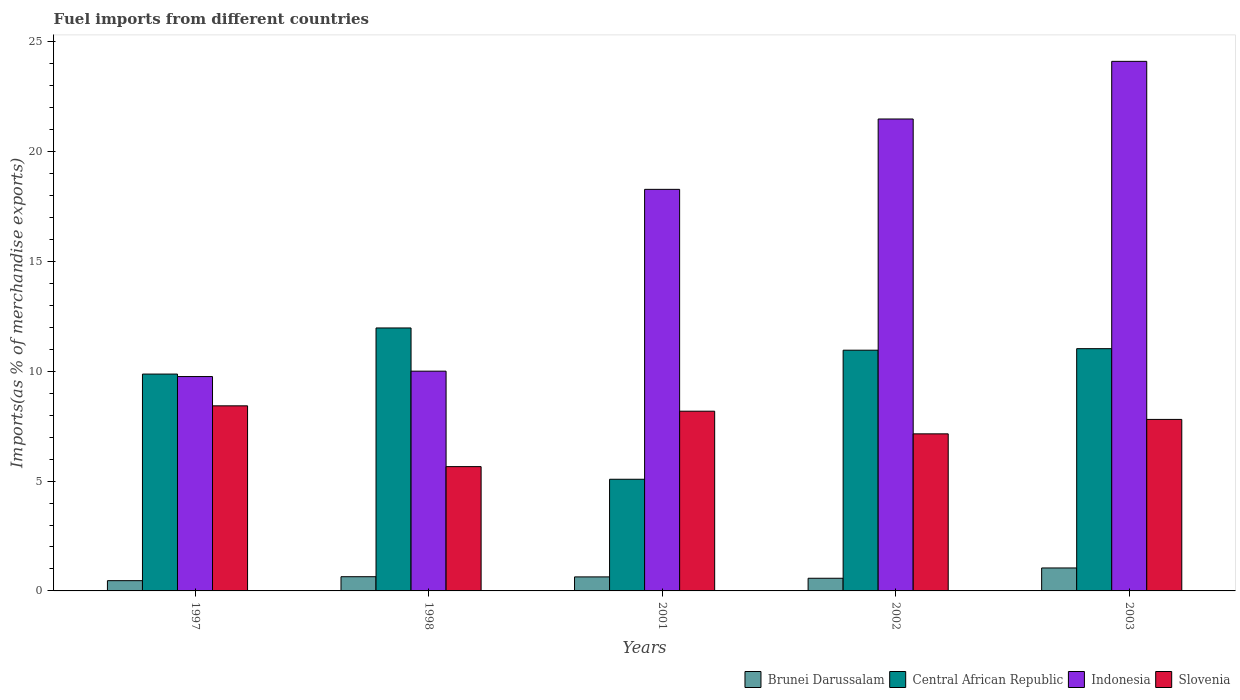How many groups of bars are there?
Give a very brief answer. 5. Are the number of bars per tick equal to the number of legend labels?
Offer a very short reply. Yes. Are the number of bars on each tick of the X-axis equal?
Ensure brevity in your answer.  Yes. How many bars are there on the 3rd tick from the left?
Provide a succinct answer. 4. How many bars are there on the 5th tick from the right?
Ensure brevity in your answer.  4. What is the label of the 2nd group of bars from the left?
Offer a very short reply. 1998. In how many cases, is the number of bars for a given year not equal to the number of legend labels?
Your response must be concise. 0. What is the percentage of imports to different countries in Slovenia in 1998?
Ensure brevity in your answer.  5.66. Across all years, what is the maximum percentage of imports to different countries in Brunei Darussalam?
Your answer should be compact. 1.05. Across all years, what is the minimum percentage of imports to different countries in Brunei Darussalam?
Offer a terse response. 0.47. In which year was the percentage of imports to different countries in Central African Republic maximum?
Your answer should be very brief. 1998. What is the total percentage of imports to different countries in Brunei Darussalam in the graph?
Make the answer very short. 3.37. What is the difference between the percentage of imports to different countries in Central African Republic in 1997 and that in 2002?
Provide a succinct answer. -1.09. What is the difference between the percentage of imports to different countries in Central African Republic in 2003 and the percentage of imports to different countries in Indonesia in 1998?
Ensure brevity in your answer.  1.02. What is the average percentage of imports to different countries in Indonesia per year?
Provide a succinct answer. 16.73. In the year 2001, what is the difference between the percentage of imports to different countries in Central African Republic and percentage of imports to different countries in Brunei Darussalam?
Ensure brevity in your answer.  4.45. What is the ratio of the percentage of imports to different countries in Indonesia in 1997 to that in 2002?
Provide a short and direct response. 0.45. Is the percentage of imports to different countries in Central African Republic in 2002 less than that in 2003?
Give a very brief answer. Yes. Is the difference between the percentage of imports to different countries in Central African Republic in 2002 and 2003 greater than the difference between the percentage of imports to different countries in Brunei Darussalam in 2002 and 2003?
Your answer should be compact. Yes. What is the difference between the highest and the second highest percentage of imports to different countries in Slovenia?
Make the answer very short. 0.24. What is the difference between the highest and the lowest percentage of imports to different countries in Central African Republic?
Provide a short and direct response. 6.89. In how many years, is the percentage of imports to different countries in Central African Republic greater than the average percentage of imports to different countries in Central African Republic taken over all years?
Your response must be concise. 4. Is the sum of the percentage of imports to different countries in Indonesia in 1998 and 2002 greater than the maximum percentage of imports to different countries in Central African Republic across all years?
Your answer should be compact. Yes. What does the 1st bar from the left in 2002 represents?
Your answer should be compact. Brunei Darussalam. What does the 4th bar from the right in 1997 represents?
Your response must be concise. Brunei Darussalam. How many bars are there?
Offer a terse response. 20. Are all the bars in the graph horizontal?
Offer a terse response. No. How many years are there in the graph?
Keep it short and to the point. 5. What is the difference between two consecutive major ticks on the Y-axis?
Give a very brief answer. 5. How many legend labels are there?
Give a very brief answer. 4. What is the title of the graph?
Ensure brevity in your answer.  Fuel imports from different countries. What is the label or title of the X-axis?
Your response must be concise. Years. What is the label or title of the Y-axis?
Keep it short and to the point. Imports(as % of merchandise exports). What is the Imports(as % of merchandise exports) in Brunei Darussalam in 1997?
Your answer should be very brief. 0.47. What is the Imports(as % of merchandise exports) in Central African Republic in 1997?
Ensure brevity in your answer.  9.87. What is the Imports(as % of merchandise exports) in Indonesia in 1997?
Your response must be concise. 9.76. What is the Imports(as % of merchandise exports) in Slovenia in 1997?
Keep it short and to the point. 8.43. What is the Imports(as % of merchandise exports) in Brunei Darussalam in 1998?
Keep it short and to the point. 0.65. What is the Imports(as % of merchandise exports) in Central African Republic in 1998?
Ensure brevity in your answer.  11.97. What is the Imports(as % of merchandise exports) in Indonesia in 1998?
Ensure brevity in your answer.  10. What is the Imports(as % of merchandise exports) of Slovenia in 1998?
Make the answer very short. 5.66. What is the Imports(as % of merchandise exports) of Brunei Darussalam in 2001?
Give a very brief answer. 0.64. What is the Imports(as % of merchandise exports) of Central African Republic in 2001?
Keep it short and to the point. 5.08. What is the Imports(as % of merchandise exports) in Indonesia in 2001?
Provide a succinct answer. 18.28. What is the Imports(as % of merchandise exports) in Slovenia in 2001?
Make the answer very short. 8.18. What is the Imports(as % of merchandise exports) of Brunei Darussalam in 2002?
Provide a succinct answer. 0.58. What is the Imports(as % of merchandise exports) in Central African Republic in 2002?
Your answer should be compact. 10.96. What is the Imports(as % of merchandise exports) of Indonesia in 2002?
Offer a very short reply. 21.48. What is the Imports(as % of merchandise exports) in Slovenia in 2002?
Offer a terse response. 7.15. What is the Imports(as % of merchandise exports) in Brunei Darussalam in 2003?
Your answer should be compact. 1.05. What is the Imports(as % of merchandise exports) in Central African Republic in 2003?
Give a very brief answer. 11.03. What is the Imports(as % of merchandise exports) of Indonesia in 2003?
Ensure brevity in your answer.  24.11. What is the Imports(as % of merchandise exports) of Slovenia in 2003?
Provide a short and direct response. 7.81. Across all years, what is the maximum Imports(as % of merchandise exports) in Brunei Darussalam?
Your response must be concise. 1.05. Across all years, what is the maximum Imports(as % of merchandise exports) of Central African Republic?
Keep it short and to the point. 11.97. Across all years, what is the maximum Imports(as % of merchandise exports) of Indonesia?
Provide a short and direct response. 24.11. Across all years, what is the maximum Imports(as % of merchandise exports) of Slovenia?
Ensure brevity in your answer.  8.43. Across all years, what is the minimum Imports(as % of merchandise exports) in Brunei Darussalam?
Keep it short and to the point. 0.47. Across all years, what is the minimum Imports(as % of merchandise exports) of Central African Republic?
Your answer should be compact. 5.08. Across all years, what is the minimum Imports(as % of merchandise exports) in Indonesia?
Your answer should be very brief. 9.76. Across all years, what is the minimum Imports(as % of merchandise exports) in Slovenia?
Give a very brief answer. 5.66. What is the total Imports(as % of merchandise exports) in Brunei Darussalam in the graph?
Your response must be concise. 3.37. What is the total Imports(as % of merchandise exports) of Central African Republic in the graph?
Ensure brevity in your answer.  48.92. What is the total Imports(as % of merchandise exports) of Indonesia in the graph?
Your answer should be very brief. 83.64. What is the total Imports(as % of merchandise exports) in Slovenia in the graph?
Ensure brevity in your answer.  37.23. What is the difference between the Imports(as % of merchandise exports) of Brunei Darussalam in 1997 and that in 1998?
Provide a short and direct response. -0.18. What is the difference between the Imports(as % of merchandise exports) of Central African Republic in 1997 and that in 1998?
Your answer should be compact. -2.1. What is the difference between the Imports(as % of merchandise exports) of Indonesia in 1997 and that in 1998?
Ensure brevity in your answer.  -0.25. What is the difference between the Imports(as % of merchandise exports) in Slovenia in 1997 and that in 1998?
Give a very brief answer. 2.77. What is the difference between the Imports(as % of merchandise exports) in Brunei Darussalam in 1997 and that in 2001?
Keep it short and to the point. -0.17. What is the difference between the Imports(as % of merchandise exports) of Central African Republic in 1997 and that in 2001?
Your response must be concise. 4.79. What is the difference between the Imports(as % of merchandise exports) in Indonesia in 1997 and that in 2001?
Offer a very short reply. -8.52. What is the difference between the Imports(as % of merchandise exports) in Slovenia in 1997 and that in 2001?
Ensure brevity in your answer.  0.24. What is the difference between the Imports(as % of merchandise exports) of Brunei Darussalam in 1997 and that in 2002?
Provide a succinct answer. -0.11. What is the difference between the Imports(as % of merchandise exports) in Central African Republic in 1997 and that in 2002?
Ensure brevity in your answer.  -1.09. What is the difference between the Imports(as % of merchandise exports) of Indonesia in 1997 and that in 2002?
Provide a short and direct response. -11.73. What is the difference between the Imports(as % of merchandise exports) of Slovenia in 1997 and that in 2002?
Give a very brief answer. 1.28. What is the difference between the Imports(as % of merchandise exports) of Brunei Darussalam in 1997 and that in 2003?
Your answer should be compact. -0.58. What is the difference between the Imports(as % of merchandise exports) in Central African Republic in 1997 and that in 2003?
Ensure brevity in your answer.  -1.16. What is the difference between the Imports(as % of merchandise exports) in Indonesia in 1997 and that in 2003?
Offer a terse response. -14.35. What is the difference between the Imports(as % of merchandise exports) in Slovenia in 1997 and that in 2003?
Provide a succinct answer. 0.62. What is the difference between the Imports(as % of merchandise exports) in Brunei Darussalam in 1998 and that in 2001?
Provide a short and direct response. 0.01. What is the difference between the Imports(as % of merchandise exports) in Central African Republic in 1998 and that in 2001?
Your response must be concise. 6.89. What is the difference between the Imports(as % of merchandise exports) in Indonesia in 1998 and that in 2001?
Ensure brevity in your answer.  -8.28. What is the difference between the Imports(as % of merchandise exports) in Slovenia in 1998 and that in 2001?
Provide a succinct answer. -2.52. What is the difference between the Imports(as % of merchandise exports) in Brunei Darussalam in 1998 and that in 2002?
Provide a succinct answer. 0.07. What is the difference between the Imports(as % of merchandise exports) in Central African Republic in 1998 and that in 2002?
Keep it short and to the point. 1.01. What is the difference between the Imports(as % of merchandise exports) in Indonesia in 1998 and that in 2002?
Keep it short and to the point. -11.48. What is the difference between the Imports(as % of merchandise exports) in Slovenia in 1998 and that in 2002?
Ensure brevity in your answer.  -1.49. What is the difference between the Imports(as % of merchandise exports) of Brunei Darussalam in 1998 and that in 2003?
Keep it short and to the point. -0.4. What is the difference between the Imports(as % of merchandise exports) in Central African Republic in 1998 and that in 2003?
Your response must be concise. 0.94. What is the difference between the Imports(as % of merchandise exports) of Indonesia in 1998 and that in 2003?
Provide a short and direct response. -14.1. What is the difference between the Imports(as % of merchandise exports) in Slovenia in 1998 and that in 2003?
Ensure brevity in your answer.  -2.15. What is the difference between the Imports(as % of merchandise exports) in Brunei Darussalam in 2001 and that in 2002?
Ensure brevity in your answer.  0.06. What is the difference between the Imports(as % of merchandise exports) in Central African Republic in 2001 and that in 2002?
Keep it short and to the point. -5.88. What is the difference between the Imports(as % of merchandise exports) in Indonesia in 2001 and that in 2002?
Provide a short and direct response. -3.2. What is the difference between the Imports(as % of merchandise exports) of Slovenia in 2001 and that in 2002?
Your response must be concise. 1.03. What is the difference between the Imports(as % of merchandise exports) in Brunei Darussalam in 2001 and that in 2003?
Keep it short and to the point. -0.41. What is the difference between the Imports(as % of merchandise exports) of Central African Republic in 2001 and that in 2003?
Provide a succinct answer. -5.95. What is the difference between the Imports(as % of merchandise exports) of Indonesia in 2001 and that in 2003?
Provide a short and direct response. -5.83. What is the difference between the Imports(as % of merchandise exports) of Slovenia in 2001 and that in 2003?
Ensure brevity in your answer.  0.37. What is the difference between the Imports(as % of merchandise exports) in Brunei Darussalam in 2002 and that in 2003?
Give a very brief answer. -0.47. What is the difference between the Imports(as % of merchandise exports) in Central African Republic in 2002 and that in 2003?
Offer a very short reply. -0.07. What is the difference between the Imports(as % of merchandise exports) in Indonesia in 2002 and that in 2003?
Offer a terse response. -2.62. What is the difference between the Imports(as % of merchandise exports) in Slovenia in 2002 and that in 2003?
Your response must be concise. -0.66. What is the difference between the Imports(as % of merchandise exports) in Brunei Darussalam in 1997 and the Imports(as % of merchandise exports) in Central African Republic in 1998?
Provide a succinct answer. -11.5. What is the difference between the Imports(as % of merchandise exports) in Brunei Darussalam in 1997 and the Imports(as % of merchandise exports) in Indonesia in 1998?
Your answer should be compact. -9.54. What is the difference between the Imports(as % of merchandise exports) of Brunei Darussalam in 1997 and the Imports(as % of merchandise exports) of Slovenia in 1998?
Ensure brevity in your answer.  -5.19. What is the difference between the Imports(as % of merchandise exports) in Central African Republic in 1997 and the Imports(as % of merchandise exports) in Indonesia in 1998?
Offer a very short reply. -0.13. What is the difference between the Imports(as % of merchandise exports) in Central African Republic in 1997 and the Imports(as % of merchandise exports) in Slovenia in 1998?
Provide a succinct answer. 4.21. What is the difference between the Imports(as % of merchandise exports) in Indonesia in 1997 and the Imports(as % of merchandise exports) in Slovenia in 1998?
Provide a short and direct response. 4.1. What is the difference between the Imports(as % of merchandise exports) in Brunei Darussalam in 1997 and the Imports(as % of merchandise exports) in Central African Republic in 2001?
Keep it short and to the point. -4.62. What is the difference between the Imports(as % of merchandise exports) of Brunei Darussalam in 1997 and the Imports(as % of merchandise exports) of Indonesia in 2001?
Provide a short and direct response. -17.82. What is the difference between the Imports(as % of merchandise exports) of Brunei Darussalam in 1997 and the Imports(as % of merchandise exports) of Slovenia in 2001?
Make the answer very short. -7.72. What is the difference between the Imports(as % of merchandise exports) of Central African Republic in 1997 and the Imports(as % of merchandise exports) of Indonesia in 2001?
Offer a very short reply. -8.41. What is the difference between the Imports(as % of merchandise exports) of Central African Republic in 1997 and the Imports(as % of merchandise exports) of Slovenia in 2001?
Give a very brief answer. 1.69. What is the difference between the Imports(as % of merchandise exports) of Indonesia in 1997 and the Imports(as % of merchandise exports) of Slovenia in 2001?
Your answer should be very brief. 1.58. What is the difference between the Imports(as % of merchandise exports) of Brunei Darussalam in 1997 and the Imports(as % of merchandise exports) of Central African Republic in 2002?
Your response must be concise. -10.49. What is the difference between the Imports(as % of merchandise exports) of Brunei Darussalam in 1997 and the Imports(as % of merchandise exports) of Indonesia in 2002?
Your response must be concise. -21.02. What is the difference between the Imports(as % of merchandise exports) of Brunei Darussalam in 1997 and the Imports(as % of merchandise exports) of Slovenia in 2002?
Make the answer very short. -6.68. What is the difference between the Imports(as % of merchandise exports) of Central African Republic in 1997 and the Imports(as % of merchandise exports) of Indonesia in 2002?
Your response must be concise. -11.61. What is the difference between the Imports(as % of merchandise exports) in Central African Republic in 1997 and the Imports(as % of merchandise exports) in Slovenia in 2002?
Ensure brevity in your answer.  2.72. What is the difference between the Imports(as % of merchandise exports) in Indonesia in 1997 and the Imports(as % of merchandise exports) in Slovenia in 2002?
Provide a succinct answer. 2.61. What is the difference between the Imports(as % of merchandise exports) of Brunei Darussalam in 1997 and the Imports(as % of merchandise exports) of Central African Republic in 2003?
Your answer should be very brief. -10.56. What is the difference between the Imports(as % of merchandise exports) in Brunei Darussalam in 1997 and the Imports(as % of merchandise exports) in Indonesia in 2003?
Keep it short and to the point. -23.64. What is the difference between the Imports(as % of merchandise exports) in Brunei Darussalam in 1997 and the Imports(as % of merchandise exports) in Slovenia in 2003?
Provide a short and direct response. -7.34. What is the difference between the Imports(as % of merchandise exports) of Central African Republic in 1997 and the Imports(as % of merchandise exports) of Indonesia in 2003?
Ensure brevity in your answer.  -14.24. What is the difference between the Imports(as % of merchandise exports) in Central African Republic in 1997 and the Imports(as % of merchandise exports) in Slovenia in 2003?
Provide a short and direct response. 2.06. What is the difference between the Imports(as % of merchandise exports) in Indonesia in 1997 and the Imports(as % of merchandise exports) in Slovenia in 2003?
Provide a short and direct response. 1.95. What is the difference between the Imports(as % of merchandise exports) of Brunei Darussalam in 1998 and the Imports(as % of merchandise exports) of Central African Republic in 2001?
Offer a terse response. -4.44. What is the difference between the Imports(as % of merchandise exports) in Brunei Darussalam in 1998 and the Imports(as % of merchandise exports) in Indonesia in 2001?
Ensure brevity in your answer.  -17.64. What is the difference between the Imports(as % of merchandise exports) in Brunei Darussalam in 1998 and the Imports(as % of merchandise exports) in Slovenia in 2001?
Keep it short and to the point. -7.54. What is the difference between the Imports(as % of merchandise exports) in Central African Republic in 1998 and the Imports(as % of merchandise exports) in Indonesia in 2001?
Your answer should be very brief. -6.31. What is the difference between the Imports(as % of merchandise exports) in Central African Republic in 1998 and the Imports(as % of merchandise exports) in Slovenia in 2001?
Your response must be concise. 3.79. What is the difference between the Imports(as % of merchandise exports) of Indonesia in 1998 and the Imports(as % of merchandise exports) of Slovenia in 2001?
Offer a terse response. 1.82. What is the difference between the Imports(as % of merchandise exports) in Brunei Darussalam in 1998 and the Imports(as % of merchandise exports) in Central African Republic in 2002?
Your answer should be very brief. -10.31. What is the difference between the Imports(as % of merchandise exports) in Brunei Darussalam in 1998 and the Imports(as % of merchandise exports) in Indonesia in 2002?
Your answer should be very brief. -20.84. What is the difference between the Imports(as % of merchandise exports) of Brunei Darussalam in 1998 and the Imports(as % of merchandise exports) of Slovenia in 2002?
Make the answer very short. -6.5. What is the difference between the Imports(as % of merchandise exports) in Central African Republic in 1998 and the Imports(as % of merchandise exports) in Indonesia in 2002?
Give a very brief answer. -9.51. What is the difference between the Imports(as % of merchandise exports) of Central African Republic in 1998 and the Imports(as % of merchandise exports) of Slovenia in 2002?
Your answer should be very brief. 4.82. What is the difference between the Imports(as % of merchandise exports) in Indonesia in 1998 and the Imports(as % of merchandise exports) in Slovenia in 2002?
Keep it short and to the point. 2.85. What is the difference between the Imports(as % of merchandise exports) in Brunei Darussalam in 1998 and the Imports(as % of merchandise exports) in Central African Republic in 2003?
Offer a very short reply. -10.38. What is the difference between the Imports(as % of merchandise exports) in Brunei Darussalam in 1998 and the Imports(as % of merchandise exports) in Indonesia in 2003?
Ensure brevity in your answer.  -23.46. What is the difference between the Imports(as % of merchandise exports) in Brunei Darussalam in 1998 and the Imports(as % of merchandise exports) in Slovenia in 2003?
Your answer should be very brief. -7.16. What is the difference between the Imports(as % of merchandise exports) in Central African Republic in 1998 and the Imports(as % of merchandise exports) in Indonesia in 2003?
Give a very brief answer. -12.14. What is the difference between the Imports(as % of merchandise exports) in Central African Republic in 1998 and the Imports(as % of merchandise exports) in Slovenia in 2003?
Offer a terse response. 4.16. What is the difference between the Imports(as % of merchandise exports) of Indonesia in 1998 and the Imports(as % of merchandise exports) of Slovenia in 2003?
Provide a succinct answer. 2.2. What is the difference between the Imports(as % of merchandise exports) of Brunei Darussalam in 2001 and the Imports(as % of merchandise exports) of Central African Republic in 2002?
Your answer should be compact. -10.32. What is the difference between the Imports(as % of merchandise exports) of Brunei Darussalam in 2001 and the Imports(as % of merchandise exports) of Indonesia in 2002?
Make the answer very short. -20.85. What is the difference between the Imports(as % of merchandise exports) of Brunei Darussalam in 2001 and the Imports(as % of merchandise exports) of Slovenia in 2002?
Give a very brief answer. -6.51. What is the difference between the Imports(as % of merchandise exports) of Central African Republic in 2001 and the Imports(as % of merchandise exports) of Indonesia in 2002?
Offer a terse response. -16.4. What is the difference between the Imports(as % of merchandise exports) of Central African Republic in 2001 and the Imports(as % of merchandise exports) of Slovenia in 2002?
Give a very brief answer. -2.07. What is the difference between the Imports(as % of merchandise exports) of Indonesia in 2001 and the Imports(as % of merchandise exports) of Slovenia in 2002?
Give a very brief answer. 11.13. What is the difference between the Imports(as % of merchandise exports) of Brunei Darussalam in 2001 and the Imports(as % of merchandise exports) of Central African Republic in 2003?
Ensure brevity in your answer.  -10.39. What is the difference between the Imports(as % of merchandise exports) of Brunei Darussalam in 2001 and the Imports(as % of merchandise exports) of Indonesia in 2003?
Your answer should be compact. -23.47. What is the difference between the Imports(as % of merchandise exports) of Brunei Darussalam in 2001 and the Imports(as % of merchandise exports) of Slovenia in 2003?
Offer a terse response. -7.17. What is the difference between the Imports(as % of merchandise exports) of Central African Republic in 2001 and the Imports(as % of merchandise exports) of Indonesia in 2003?
Your answer should be compact. -19.03. What is the difference between the Imports(as % of merchandise exports) of Central African Republic in 2001 and the Imports(as % of merchandise exports) of Slovenia in 2003?
Make the answer very short. -2.72. What is the difference between the Imports(as % of merchandise exports) in Indonesia in 2001 and the Imports(as % of merchandise exports) in Slovenia in 2003?
Your answer should be very brief. 10.47. What is the difference between the Imports(as % of merchandise exports) in Brunei Darussalam in 2002 and the Imports(as % of merchandise exports) in Central African Republic in 2003?
Give a very brief answer. -10.45. What is the difference between the Imports(as % of merchandise exports) of Brunei Darussalam in 2002 and the Imports(as % of merchandise exports) of Indonesia in 2003?
Provide a short and direct response. -23.53. What is the difference between the Imports(as % of merchandise exports) in Brunei Darussalam in 2002 and the Imports(as % of merchandise exports) in Slovenia in 2003?
Give a very brief answer. -7.23. What is the difference between the Imports(as % of merchandise exports) in Central African Republic in 2002 and the Imports(as % of merchandise exports) in Indonesia in 2003?
Ensure brevity in your answer.  -13.15. What is the difference between the Imports(as % of merchandise exports) in Central African Republic in 2002 and the Imports(as % of merchandise exports) in Slovenia in 2003?
Ensure brevity in your answer.  3.15. What is the difference between the Imports(as % of merchandise exports) of Indonesia in 2002 and the Imports(as % of merchandise exports) of Slovenia in 2003?
Give a very brief answer. 13.68. What is the average Imports(as % of merchandise exports) of Brunei Darussalam per year?
Provide a succinct answer. 0.67. What is the average Imports(as % of merchandise exports) in Central African Republic per year?
Ensure brevity in your answer.  9.78. What is the average Imports(as % of merchandise exports) of Indonesia per year?
Your response must be concise. 16.73. What is the average Imports(as % of merchandise exports) in Slovenia per year?
Your response must be concise. 7.45. In the year 1997, what is the difference between the Imports(as % of merchandise exports) of Brunei Darussalam and Imports(as % of merchandise exports) of Central African Republic?
Ensure brevity in your answer.  -9.41. In the year 1997, what is the difference between the Imports(as % of merchandise exports) of Brunei Darussalam and Imports(as % of merchandise exports) of Indonesia?
Ensure brevity in your answer.  -9.29. In the year 1997, what is the difference between the Imports(as % of merchandise exports) in Brunei Darussalam and Imports(as % of merchandise exports) in Slovenia?
Provide a succinct answer. -7.96. In the year 1997, what is the difference between the Imports(as % of merchandise exports) in Central African Republic and Imports(as % of merchandise exports) in Indonesia?
Your answer should be very brief. 0.11. In the year 1997, what is the difference between the Imports(as % of merchandise exports) of Central African Republic and Imports(as % of merchandise exports) of Slovenia?
Your response must be concise. 1.45. In the year 1997, what is the difference between the Imports(as % of merchandise exports) in Indonesia and Imports(as % of merchandise exports) in Slovenia?
Give a very brief answer. 1.33. In the year 1998, what is the difference between the Imports(as % of merchandise exports) of Brunei Darussalam and Imports(as % of merchandise exports) of Central African Republic?
Give a very brief answer. -11.32. In the year 1998, what is the difference between the Imports(as % of merchandise exports) of Brunei Darussalam and Imports(as % of merchandise exports) of Indonesia?
Your response must be concise. -9.36. In the year 1998, what is the difference between the Imports(as % of merchandise exports) in Brunei Darussalam and Imports(as % of merchandise exports) in Slovenia?
Make the answer very short. -5.01. In the year 1998, what is the difference between the Imports(as % of merchandise exports) of Central African Republic and Imports(as % of merchandise exports) of Indonesia?
Offer a terse response. 1.97. In the year 1998, what is the difference between the Imports(as % of merchandise exports) of Central African Republic and Imports(as % of merchandise exports) of Slovenia?
Make the answer very short. 6.31. In the year 1998, what is the difference between the Imports(as % of merchandise exports) in Indonesia and Imports(as % of merchandise exports) in Slovenia?
Give a very brief answer. 4.35. In the year 2001, what is the difference between the Imports(as % of merchandise exports) in Brunei Darussalam and Imports(as % of merchandise exports) in Central African Republic?
Offer a terse response. -4.45. In the year 2001, what is the difference between the Imports(as % of merchandise exports) of Brunei Darussalam and Imports(as % of merchandise exports) of Indonesia?
Provide a short and direct response. -17.64. In the year 2001, what is the difference between the Imports(as % of merchandise exports) in Brunei Darussalam and Imports(as % of merchandise exports) in Slovenia?
Ensure brevity in your answer.  -7.54. In the year 2001, what is the difference between the Imports(as % of merchandise exports) of Central African Republic and Imports(as % of merchandise exports) of Indonesia?
Keep it short and to the point. -13.2. In the year 2001, what is the difference between the Imports(as % of merchandise exports) of Central African Republic and Imports(as % of merchandise exports) of Slovenia?
Your answer should be compact. -3.1. In the year 2001, what is the difference between the Imports(as % of merchandise exports) of Indonesia and Imports(as % of merchandise exports) of Slovenia?
Give a very brief answer. 10.1. In the year 2002, what is the difference between the Imports(as % of merchandise exports) of Brunei Darussalam and Imports(as % of merchandise exports) of Central African Republic?
Offer a very short reply. -10.38. In the year 2002, what is the difference between the Imports(as % of merchandise exports) in Brunei Darussalam and Imports(as % of merchandise exports) in Indonesia?
Your response must be concise. -20.91. In the year 2002, what is the difference between the Imports(as % of merchandise exports) in Brunei Darussalam and Imports(as % of merchandise exports) in Slovenia?
Provide a succinct answer. -6.57. In the year 2002, what is the difference between the Imports(as % of merchandise exports) of Central African Republic and Imports(as % of merchandise exports) of Indonesia?
Keep it short and to the point. -10.53. In the year 2002, what is the difference between the Imports(as % of merchandise exports) of Central African Republic and Imports(as % of merchandise exports) of Slovenia?
Ensure brevity in your answer.  3.81. In the year 2002, what is the difference between the Imports(as % of merchandise exports) of Indonesia and Imports(as % of merchandise exports) of Slovenia?
Keep it short and to the point. 14.33. In the year 2003, what is the difference between the Imports(as % of merchandise exports) in Brunei Darussalam and Imports(as % of merchandise exports) in Central African Republic?
Provide a succinct answer. -9.98. In the year 2003, what is the difference between the Imports(as % of merchandise exports) in Brunei Darussalam and Imports(as % of merchandise exports) in Indonesia?
Provide a short and direct response. -23.06. In the year 2003, what is the difference between the Imports(as % of merchandise exports) of Brunei Darussalam and Imports(as % of merchandise exports) of Slovenia?
Your answer should be very brief. -6.76. In the year 2003, what is the difference between the Imports(as % of merchandise exports) of Central African Republic and Imports(as % of merchandise exports) of Indonesia?
Ensure brevity in your answer.  -13.08. In the year 2003, what is the difference between the Imports(as % of merchandise exports) in Central African Republic and Imports(as % of merchandise exports) in Slovenia?
Keep it short and to the point. 3.22. In the year 2003, what is the difference between the Imports(as % of merchandise exports) of Indonesia and Imports(as % of merchandise exports) of Slovenia?
Your response must be concise. 16.3. What is the ratio of the Imports(as % of merchandise exports) in Brunei Darussalam in 1997 to that in 1998?
Provide a succinct answer. 0.72. What is the ratio of the Imports(as % of merchandise exports) of Central African Republic in 1997 to that in 1998?
Provide a succinct answer. 0.82. What is the ratio of the Imports(as % of merchandise exports) of Indonesia in 1997 to that in 1998?
Keep it short and to the point. 0.98. What is the ratio of the Imports(as % of merchandise exports) in Slovenia in 1997 to that in 1998?
Ensure brevity in your answer.  1.49. What is the ratio of the Imports(as % of merchandise exports) of Brunei Darussalam in 1997 to that in 2001?
Provide a succinct answer. 0.73. What is the ratio of the Imports(as % of merchandise exports) of Central African Republic in 1997 to that in 2001?
Give a very brief answer. 1.94. What is the ratio of the Imports(as % of merchandise exports) in Indonesia in 1997 to that in 2001?
Your response must be concise. 0.53. What is the ratio of the Imports(as % of merchandise exports) of Slovenia in 1997 to that in 2001?
Give a very brief answer. 1.03. What is the ratio of the Imports(as % of merchandise exports) of Brunei Darussalam in 1997 to that in 2002?
Offer a terse response. 0.81. What is the ratio of the Imports(as % of merchandise exports) in Central African Republic in 1997 to that in 2002?
Provide a short and direct response. 0.9. What is the ratio of the Imports(as % of merchandise exports) in Indonesia in 1997 to that in 2002?
Your response must be concise. 0.45. What is the ratio of the Imports(as % of merchandise exports) of Slovenia in 1997 to that in 2002?
Your answer should be compact. 1.18. What is the ratio of the Imports(as % of merchandise exports) in Brunei Darussalam in 1997 to that in 2003?
Give a very brief answer. 0.45. What is the ratio of the Imports(as % of merchandise exports) of Central African Republic in 1997 to that in 2003?
Provide a succinct answer. 0.9. What is the ratio of the Imports(as % of merchandise exports) of Indonesia in 1997 to that in 2003?
Make the answer very short. 0.4. What is the ratio of the Imports(as % of merchandise exports) in Slovenia in 1997 to that in 2003?
Provide a short and direct response. 1.08. What is the ratio of the Imports(as % of merchandise exports) of Brunei Darussalam in 1998 to that in 2001?
Your answer should be very brief. 1.01. What is the ratio of the Imports(as % of merchandise exports) in Central African Republic in 1998 to that in 2001?
Provide a succinct answer. 2.35. What is the ratio of the Imports(as % of merchandise exports) in Indonesia in 1998 to that in 2001?
Offer a very short reply. 0.55. What is the ratio of the Imports(as % of merchandise exports) of Slovenia in 1998 to that in 2001?
Give a very brief answer. 0.69. What is the ratio of the Imports(as % of merchandise exports) in Brunei Darussalam in 1998 to that in 2002?
Keep it short and to the point. 1.12. What is the ratio of the Imports(as % of merchandise exports) in Central African Republic in 1998 to that in 2002?
Keep it short and to the point. 1.09. What is the ratio of the Imports(as % of merchandise exports) of Indonesia in 1998 to that in 2002?
Offer a very short reply. 0.47. What is the ratio of the Imports(as % of merchandise exports) of Slovenia in 1998 to that in 2002?
Provide a short and direct response. 0.79. What is the ratio of the Imports(as % of merchandise exports) in Brunei Darussalam in 1998 to that in 2003?
Offer a very short reply. 0.62. What is the ratio of the Imports(as % of merchandise exports) in Central African Republic in 1998 to that in 2003?
Offer a very short reply. 1.09. What is the ratio of the Imports(as % of merchandise exports) of Indonesia in 1998 to that in 2003?
Ensure brevity in your answer.  0.41. What is the ratio of the Imports(as % of merchandise exports) in Slovenia in 1998 to that in 2003?
Your response must be concise. 0.72. What is the ratio of the Imports(as % of merchandise exports) in Brunei Darussalam in 2001 to that in 2002?
Give a very brief answer. 1.11. What is the ratio of the Imports(as % of merchandise exports) in Central African Republic in 2001 to that in 2002?
Give a very brief answer. 0.46. What is the ratio of the Imports(as % of merchandise exports) of Indonesia in 2001 to that in 2002?
Give a very brief answer. 0.85. What is the ratio of the Imports(as % of merchandise exports) in Slovenia in 2001 to that in 2002?
Keep it short and to the point. 1.14. What is the ratio of the Imports(as % of merchandise exports) in Brunei Darussalam in 2001 to that in 2003?
Offer a terse response. 0.61. What is the ratio of the Imports(as % of merchandise exports) of Central African Republic in 2001 to that in 2003?
Provide a succinct answer. 0.46. What is the ratio of the Imports(as % of merchandise exports) in Indonesia in 2001 to that in 2003?
Offer a terse response. 0.76. What is the ratio of the Imports(as % of merchandise exports) in Slovenia in 2001 to that in 2003?
Your answer should be very brief. 1.05. What is the ratio of the Imports(as % of merchandise exports) in Brunei Darussalam in 2002 to that in 2003?
Offer a terse response. 0.55. What is the ratio of the Imports(as % of merchandise exports) in Central African Republic in 2002 to that in 2003?
Make the answer very short. 0.99. What is the ratio of the Imports(as % of merchandise exports) in Indonesia in 2002 to that in 2003?
Your answer should be very brief. 0.89. What is the ratio of the Imports(as % of merchandise exports) of Slovenia in 2002 to that in 2003?
Your answer should be compact. 0.92. What is the difference between the highest and the second highest Imports(as % of merchandise exports) in Brunei Darussalam?
Your answer should be compact. 0.4. What is the difference between the highest and the second highest Imports(as % of merchandise exports) in Central African Republic?
Provide a short and direct response. 0.94. What is the difference between the highest and the second highest Imports(as % of merchandise exports) in Indonesia?
Give a very brief answer. 2.62. What is the difference between the highest and the second highest Imports(as % of merchandise exports) of Slovenia?
Offer a very short reply. 0.24. What is the difference between the highest and the lowest Imports(as % of merchandise exports) of Brunei Darussalam?
Ensure brevity in your answer.  0.58. What is the difference between the highest and the lowest Imports(as % of merchandise exports) of Central African Republic?
Keep it short and to the point. 6.89. What is the difference between the highest and the lowest Imports(as % of merchandise exports) of Indonesia?
Keep it short and to the point. 14.35. What is the difference between the highest and the lowest Imports(as % of merchandise exports) of Slovenia?
Keep it short and to the point. 2.77. 